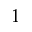<formula> <loc_0><loc_0><loc_500><loc_500>1</formula> 